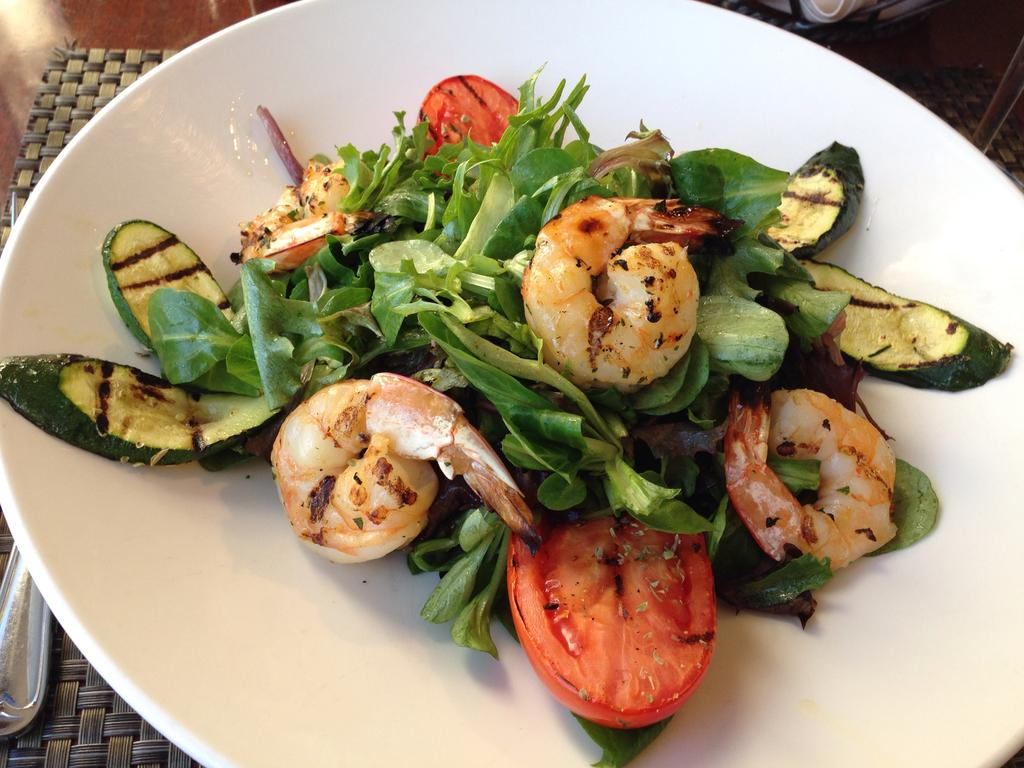What is on the white plate in the image? There is food on a white plate in the image. What is under the white plate in the image? There is a table mat in the image. What utensil is present on the table in the image? There is a fork on the table in the image. How many cows are visible in the image? There are no cows present in the image. What type of skate is being used by the person in the image? There is no person or skate present in the image. 